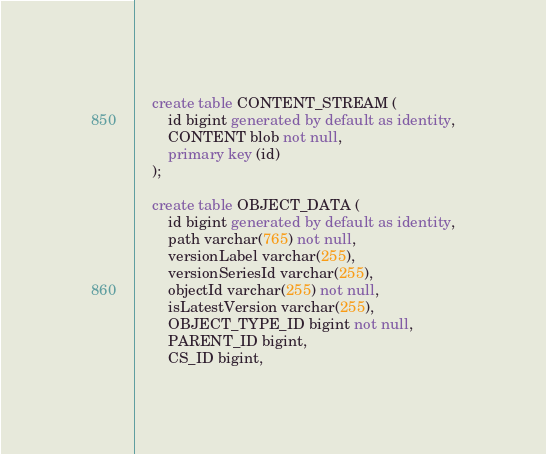Convert code to text. <code><loc_0><loc_0><loc_500><loc_500><_SQL_>
    create table CONTENT_STREAM (
        id bigint generated by default as identity,
        CONTENT blob not null,
        primary key (id)
    );

    create table OBJECT_DATA (
        id bigint generated by default as identity,
        path varchar(765) not null,
        versionLabel varchar(255),
        versionSeriesId varchar(255),
        objectId varchar(255) not null,
        isLatestVersion varchar(255),
        OBJECT_TYPE_ID bigint not null,
        PARENT_ID bigint,
        CS_ID bigint,</code> 